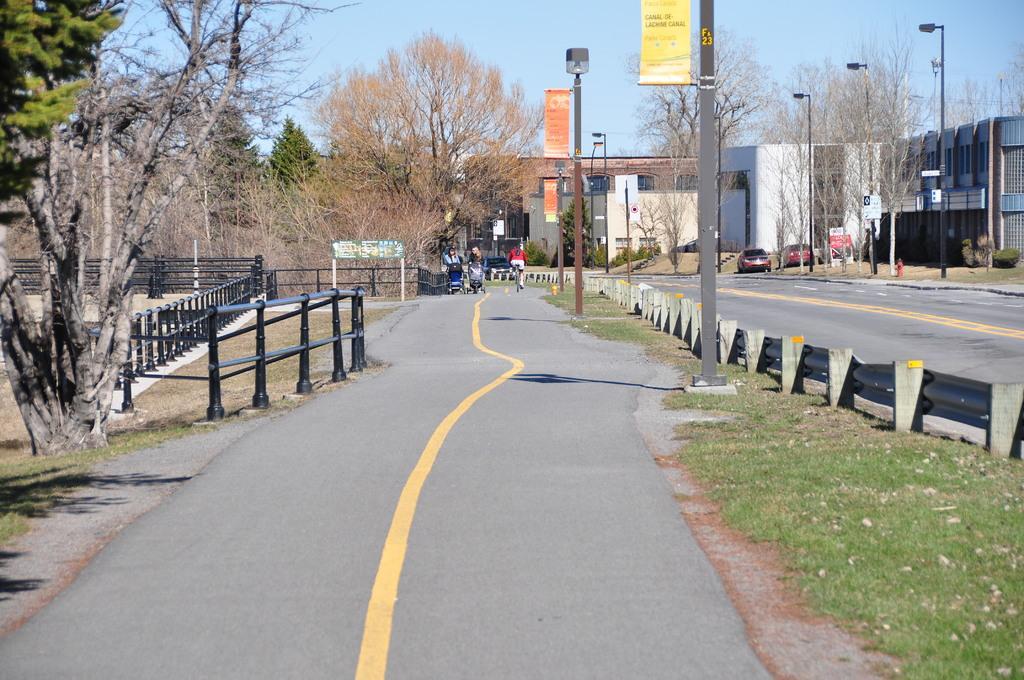How would you summarize this image in a sentence or two? In this picture, there is a road in the center. On the road, there are two women holding baby vehicles. Beside them there is a person riding bicycle. Towards the right, there is another road. In between the words, there is a fence and poles. Towards the right, there are buildings, trees, poles and vehicles. Towards the left, there are trees and a fence. On the top, there is a sky. 